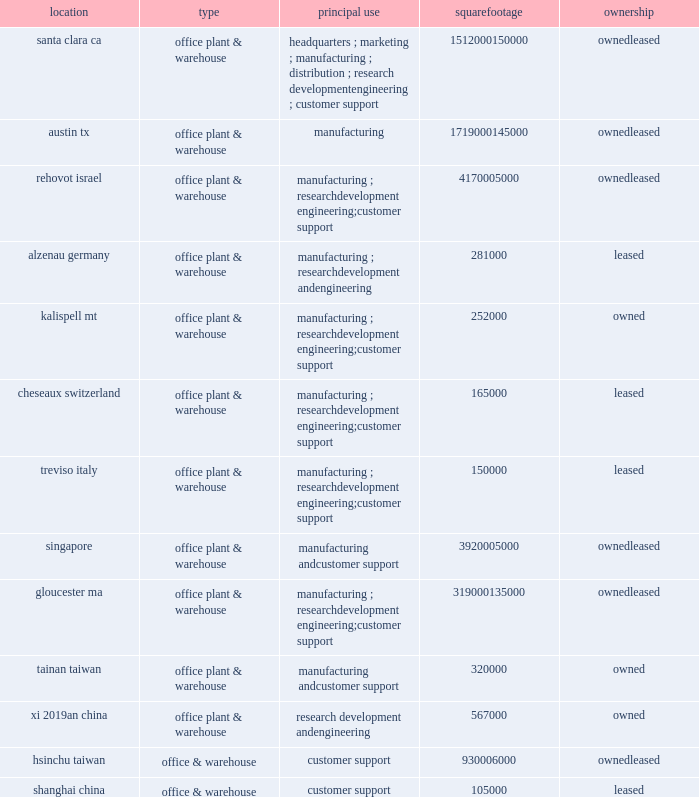Item 2 : properties information concerning applied 2019s principal properties at october 28 , 2012 is set forth below : location type principal use square footage ownership santa clara , ca .
Office , plant & warehouse headquarters ; marketing ; manufacturing ; distribution ; research , development , engineering ; customer support 1512000 150000 leased austin , tx .
Office , plant & warehouse manufacturing 1719000 145000 leased rehovot , israel .
Office , plant & warehouse manufacturing ; research , development , engineering ; customer support 417000 leased alzenau , germany .
Office , plant & warehouse manufacturing ; research , development and engineering 281000 leased kalispell , mt .
Office , plant & warehouse manufacturing ; research , development , engineering ; customer support 252000 owned cheseaux , switzerland .
Office , plant & warehouse manufacturing ; research , development , engineering ; customer support 165000 leased treviso , italy .
Office , plant & warehouse manufacturing ; research , development , engineering ; customer support 150000 leased singapore .
Office , plant & warehouse manufacturing and customer support 392000 leased gloucester , ma .
Office , plant & warehouse manufacturing ; research , development , engineering ; customer support 319000 135000 leased tainan , taiwan .
Office , plant & warehouse manufacturing and customer support 320000 owned xi 2019an , china .
Office , plant & warehouse research , development and engineering 567000 owned hsinchu , taiwan .
Office & warehouse customer support 93000 leased .
Because of the interrelation of applied 2019s operations , properties within a country may be shared by the segments operating within that country .
Products in the silicon systems group are manufactured in austin , texas ; gloucester , massachusetts ; rehovot , israel ; and singapore .
Remanufactured products in the applied global services segment are produced primarily in austin , texas .
Products in the display segment are manufactured in santa clara , california ; alzenau , germany ; and tainan , taiwan .
Products in the energy and environmental solutions segment are primarily manufactured in alzenau , germany ; cheseaux , switzerland ; and treviso , italy .
In addition to the above properties , applied leases office space for marketing , sales , engineering and customer support offices in 79 locations throughout the world : 17 in europe , 23 in japan , 16 in north america ( principally the united states ) , 7 in china , 7 in korea , 6 in southeast asia , and 3 in taiwan .
Applied also owns 112 acres of buildable land in texas that could accommodate approximately 1708000 square feet of additional building space , 12.5 acres in california that could accommodate approximately 400000 square feet of additional building space , 10.8 acres in massachusetts that could accommodate approximately 65000 square feet of additional building space and 10 acres in israel that could accommodate approximately 111000 square feet of additional building space .
Applied also leases 4 acres in italy that could accommodate approximately 180000 square feet of additional building space .
Applied considers the properties that it owns or leases as adequate to meet its current and future requirements .
Applied regularly assesses the size , capability and location of its global infrastructure and periodically makes adjustments based on these assessments. .
What is the total square footage of office & warehouse customer support 93000 leased in china? 
Computations: (567000 + 105000)
Answer: 672000.0. 